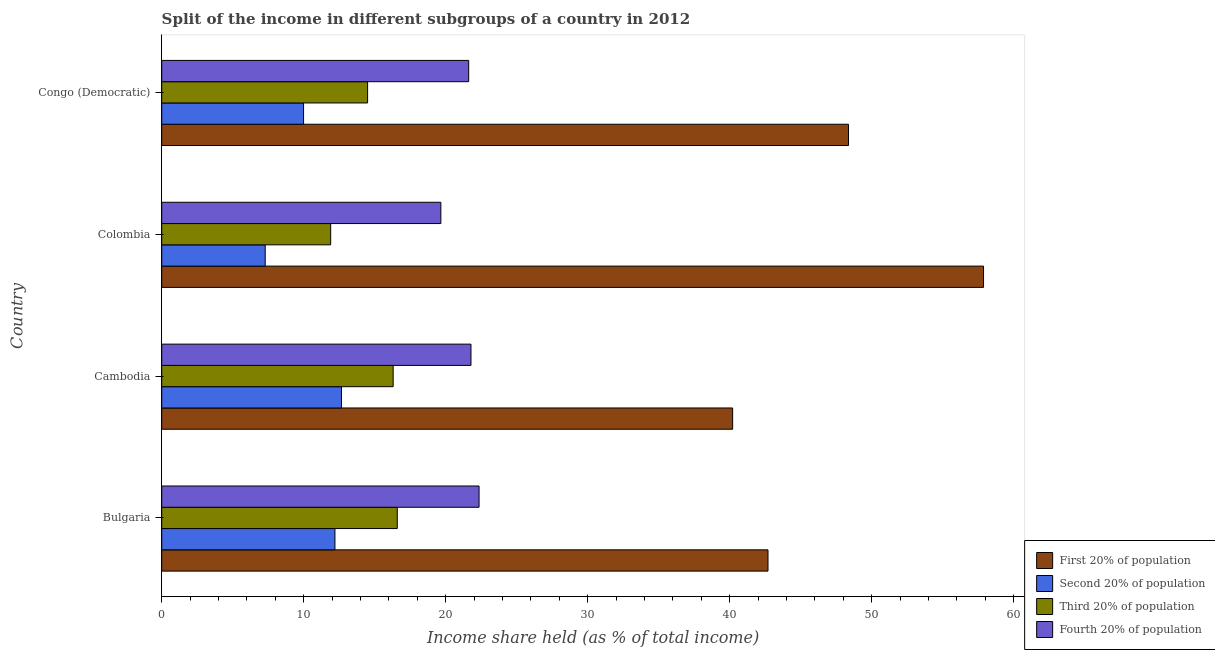How many different coloured bars are there?
Your answer should be very brief. 4. How many groups of bars are there?
Provide a succinct answer. 4. Are the number of bars per tick equal to the number of legend labels?
Give a very brief answer. Yes. How many bars are there on the 1st tick from the top?
Your answer should be very brief. 4. What is the label of the 3rd group of bars from the top?
Offer a very short reply. Cambodia. What is the share of the income held by fourth 20% of the population in Congo (Democratic)?
Offer a very short reply. 21.62. Across all countries, what is the maximum share of the income held by first 20% of the population?
Provide a short and direct response. 57.88. Across all countries, what is the minimum share of the income held by third 20% of the population?
Provide a short and direct response. 11.9. In which country was the share of the income held by second 20% of the population maximum?
Provide a short and direct response. Cambodia. What is the total share of the income held by third 20% of the population in the graph?
Keep it short and to the point. 59.29. What is the difference between the share of the income held by second 20% of the population in Bulgaria and that in Cambodia?
Give a very brief answer. -0.46. What is the difference between the share of the income held by second 20% of the population in Bulgaria and the share of the income held by first 20% of the population in Congo (Democratic)?
Give a very brief answer. -36.17. What is the average share of the income held by first 20% of the population per country?
Offer a terse response. 47.29. What is the difference between the share of the income held by fourth 20% of the population and share of the income held by second 20% of the population in Colombia?
Provide a short and direct response. 12.37. What is the ratio of the share of the income held by second 20% of the population in Colombia to that in Congo (Democratic)?
Offer a very short reply. 0.73. What is the difference between the highest and the second highest share of the income held by second 20% of the population?
Ensure brevity in your answer.  0.46. What is the difference between the highest and the lowest share of the income held by fourth 20% of the population?
Your answer should be very brief. 2.69. What does the 1st bar from the top in Bulgaria represents?
Offer a very short reply. Fourth 20% of population. What does the 4th bar from the bottom in Cambodia represents?
Provide a short and direct response. Fourth 20% of population. How many bars are there?
Give a very brief answer. 16. How many countries are there in the graph?
Ensure brevity in your answer.  4. Are the values on the major ticks of X-axis written in scientific E-notation?
Provide a short and direct response. No. Does the graph contain any zero values?
Provide a short and direct response. No. Does the graph contain grids?
Keep it short and to the point. No. How are the legend labels stacked?
Your response must be concise. Vertical. What is the title of the graph?
Offer a very short reply. Split of the income in different subgroups of a country in 2012. Does "UNDP" appear as one of the legend labels in the graph?
Offer a very short reply. No. What is the label or title of the X-axis?
Offer a very short reply. Income share held (as % of total income). What is the label or title of the Y-axis?
Give a very brief answer. Country. What is the Income share held (as % of total income) in First 20% of population in Bulgaria?
Your response must be concise. 42.7. What is the Income share held (as % of total income) in Second 20% of population in Bulgaria?
Ensure brevity in your answer.  12.2. What is the Income share held (as % of total income) of Third 20% of population in Bulgaria?
Your answer should be very brief. 16.59. What is the Income share held (as % of total income) of Fourth 20% of population in Bulgaria?
Provide a short and direct response. 22.35. What is the Income share held (as % of total income) in First 20% of population in Cambodia?
Your response must be concise. 40.21. What is the Income share held (as % of total income) in Second 20% of population in Cambodia?
Ensure brevity in your answer.  12.66. What is the Income share held (as % of total income) of Fourth 20% of population in Cambodia?
Provide a succinct answer. 21.78. What is the Income share held (as % of total income) of First 20% of population in Colombia?
Keep it short and to the point. 57.88. What is the Income share held (as % of total income) of Second 20% of population in Colombia?
Your response must be concise. 7.29. What is the Income share held (as % of total income) in Fourth 20% of population in Colombia?
Offer a very short reply. 19.66. What is the Income share held (as % of total income) of First 20% of population in Congo (Democratic)?
Your answer should be compact. 48.37. What is the Income share held (as % of total income) of Second 20% of population in Congo (Democratic)?
Provide a short and direct response. 9.99. What is the Income share held (as % of total income) of Third 20% of population in Congo (Democratic)?
Give a very brief answer. 14.5. What is the Income share held (as % of total income) of Fourth 20% of population in Congo (Democratic)?
Provide a short and direct response. 21.62. Across all countries, what is the maximum Income share held (as % of total income) in First 20% of population?
Give a very brief answer. 57.88. Across all countries, what is the maximum Income share held (as % of total income) of Second 20% of population?
Provide a short and direct response. 12.66. Across all countries, what is the maximum Income share held (as % of total income) of Third 20% of population?
Give a very brief answer. 16.59. Across all countries, what is the maximum Income share held (as % of total income) of Fourth 20% of population?
Offer a terse response. 22.35. Across all countries, what is the minimum Income share held (as % of total income) in First 20% of population?
Make the answer very short. 40.21. Across all countries, what is the minimum Income share held (as % of total income) of Second 20% of population?
Provide a short and direct response. 7.29. Across all countries, what is the minimum Income share held (as % of total income) of Third 20% of population?
Your answer should be compact. 11.9. Across all countries, what is the minimum Income share held (as % of total income) in Fourth 20% of population?
Provide a succinct answer. 19.66. What is the total Income share held (as % of total income) of First 20% of population in the graph?
Provide a short and direct response. 189.16. What is the total Income share held (as % of total income) in Second 20% of population in the graph?
Make the answer very short. 42.14. What is the total Income share held (as % of total income) of Third 20% of population in the graph?
Ensure brevity in your answer.  59.29. What is the total Income share held (as % of total income) of Fourth 20% of population in the graph?
Provide a short and direct response. 85.41. What is the difference between the Income share held (as % of total income) of First 20% of population in Bulgaria and that in Cambodia?
Ensure brevity in your answer.  2.49. What is the difference between the Income share held (as % of total income) in Second 20% of population in Bulgaria and that in Cambodia?
Your answer should be very brief. -0.46. What is the difference between the Income share held (as % of total income) in Third 20% of population in Bulgaria and that in Cambodia?
Your answer should be very brief. 0.29. What is the difference between the Income share held (as % of total income) in Fourth 20% of population in Bulgaria and that in Cambodia?
Keep it short and to the point. 0.57. What is the difference between the Income share held (as % of total income) in First 20% of population in Bulgaria and that in Colombia?
Provide a short and direct response. -15.18. What is the difference between the Income share held (as % of total income) in Second 20% of population in Bulgaria and that in Colombia?
Your answer should be compact. 4.91. What is the difference between the Income share held (as % of total income) of Third 20% of population in Bulgaria and that in Colombia?
Provide a succinct answer. 4.69. What is the difference between the Income share held (as % of total income) in Fourth 20% of population in Bulgaria and that in Colombia?
Keep it short and to the point. 2.69. What is the difference between the Income share held (as % of total income) of First 20% of population in Bulgaria and that in Congo (Democratic)?
Provide a succinct answer. -5.67. What is the difference between the Income share held (as % of total income) in Second 20% of population in Bulgaria and that in Congo (Democratic)?
Ensure brevity in your answer.  2.21. What is the difference between the Income share held (as % of total income) in Third 20% of population in Bulgaria and that in Congo (Democratic)?
Your answer should be very brief. 2.09. What is the difference between the Income share held (as % of total income) in Fourth 20% of population in Bulgaria and that in Congo (Democratic)?
Provide a succinct answer. 0.73. What is the difference between the Income share held (as % of total income) in First 20% of population in Cambodia and that in Colombia?
Provide a short and direct response. -17.67. What is the difference between the Income share held (as % of total income) of Second 20% of population in Cambodia and that in Colombia?
Your response must be concise. 5.37. What is the difference between the Income share held (as % of total income) of Third 20% of population in Cambodia and that in Colombia?
Provide a short and direct response. 4.4. What is the difference between the Income share held (as % of total income) of Fourth 20% of population in Cambodia and that in Colombia?
Your answer should be very brief. 2.12. What is the difference between the Income share held (as % of total income) of First 20% of population in Cambodia and that in Congo (Democratic)?
Provide a short and direct response. -8.16. What is the difference between the Income share held (as % of total income) of Second 20% of population in Cambodia and that in Congo (Democratic)?
Make the answer very short. 2.67. What is the difference between the Income share held (as % of total income) in Third 20% of population in Cambodia and that in Congo (Democratic)?
Your answer should be compact. 1.8. What is the difference between the Income share held (as % of total income) in Fourth 20% of population in Cambodia and that in Congo (Democratic)?
Give a very brief answer. 0.16. What is the difference between the Income share held (as % of total income) in First 20% of population in Colombia and that in Congo (Democratic)?
Ensure brevity in your answer.  9.51. What is the difference between the Income share held (as % of total income) of Second 20% of population in Colombia and that in Congo (Democratic)?
Provide a short and direct response. -2.7. What is the difference between the Income share held (as % of total income) in Fourth 20% of population in Colombia and that in Congo (Democratic)?
Provide a succinct answer. -1.96. What is the difference between the Income share held (as % of total income) of First 20% of population in Bulgaria and the Income share held (as % of total income) of Second 20% of population in Cambodia?
Offer a terse response. 30.04. What is the difference between the Income share held (as % of total income) in First 20% of population in Bulgaria and the Income share held (as % of total income) in Third 20% of population in Cambodia?
Your answer should be compact. 26.4. What is the difference between the Income share held (as % of total income) in First 20% of population in Bulgaria and the Income share held (as % of total income) in Fourth 20% of population in Cambodia?
Offer a terse response. 20.92. What is the difference between the Income share held (as % of total income) in Second 20% of population in Bulgaria and the Income share held (as % of total income) in Third 20% of population in Cambodia?
Provide a short and direct response. -4.1. What is the difference between the Income share held (as % of total income) in Second 20% of population in Bulgaria and the Income share held (as % of total income) in Fourth 20% of population in Cambodia?
Make the answer very short. -9.58. What is the difference between the Income share held (as % of total income) in Third 20% of population in Bulgaria and the Income share held (as % of total income) in Fourth 20% of population in Cambodia?
Keep it short and to the point. -5.19. What is the difference between the Income share held (as % of total income) in First 20% of population in Bulgaria and the Income share held (as % of total income) in Second 20% of population in Colombia?
Your answer should be compact. 35.41. What is the difference between the Income share held (as % of total income) in First 20% of population in Bulgaria and the Income share held (as % of total income) in Third 20% of population in Colombia?
Your answer should be compact. 30.8. What is the difference between the Income share held (as % of total income) of First 20% of population in Bulgaria and the Income share held (as % of total income) of Fourth 20% of population in Colombia?
Ensure brevity in your answer.  23.04. What is the difference between the Income share held (as % of total income) in Second 20% of population in Bulgaria and the Income share held (as % of total income) in Third 20% of population in Colombia?
Your answer should be compact. 0.3. What is the difference between the Income share held (as % of total income) in Second 20% of population in Bulgaria and the Income share held (as % of total income) in Fourth 20% of population in Colombia?
Ensure brevity in your answer.  -7.46. What is the difference between the Income share held (as % of total income) in Third 20% of population in Bulgaria and the Income share held (as % of total income) in Fourth 20% of population in Colombia?
Your answer should be very brief. -3.07. What is the difference between the Income share held (as % of total income) of First 20% of population in Bulgaria and the Income share held (as % of total income) of Second 20% of population in Congo (Democratic)?
Provide a succinct answer. 32.71. What is the difference between the Income share held (as % of total income) in First 20% of population in Bulgaria and the Income share held (as % of total income) in Third 20% of population in Congo (Democratic)?
Make the answer very short. 28.2. What is the difference between the Income share held (as % of total income) in First 20% of population in Bulgaria and the Income share held (as % of total income) in Fourth 20% of population in Congo (Democratic)?
Provide a short and direct response. 21.08. What is the difference between the Income share held (as % of total income) in Second 20% of population in Bulgaria and the Income share held (as % of total income) in Third 20% of population in Congo (Democratic)?
Your answer should be very brief. -2.3. What is the difference between the Income share held (as % of total income) of Second 20% of population in Bulgaria and the Income share held (as % of total income) of Fourth 20% of population in Congo (Democratic)?
Keep it short and to the point. -9.42. What is the difference between the Income share held (as % of total income) in Third 20% of population in Bulgaria and the Income share held (as % of total income) in Fourth 20% of population in Congo (Democratic)?
Offer a terse response. -5.03. What is the difference between the Income share held (as % of total income) of First 20% of population in Cambodia and the Income share held (as % of total income) of Second 20% of population in Colombia?
Provide a short and direct response. 32.92. What is the difference between the Income share held (as % of total income) in First 20% of population in Cambodia and the Income share held (as % of total income) in Third 20% of population in Colombia?
Provide a short and direct response. 28.31. What is the difference between the Income share held (as % of total income) in First 20% of population in Cambodia and the Income share held (as % of total income) in Fourth 20% of population in Colombia?
Your answer should be compact. 20.55. What is the difference between the Income share held (as % of total income) of Second 20% of population in Cambodia and the Income share held (as % of total income) of Third 20% of population in Colombia?
Your answer should be compact. 0.76. What is the difference between the Income share held (as % of total income) in Second 20% of population in Cambodia and the Income share held (as % of total income) in Fourth 20% of population in Colombia?
Offer a very short reply. -7. What is the difference between the Income share held (as % of total income) of Third 20% of population in Cambodia and the Income share held (as % of total income) of Fourth 20% of population in Colombia?
Make the answer very short. -3.36. What is the difference between the Income share held (as % of total income) of First 20% of population in Cambodia and the Income share held (as % of total income) of Second 20% of population in Congo (Democratic)?
Give a very brief answer. 30.22. What is the difference between the Income share held (as % of total income) in First 20% of population in Cambodia and the Income share held (as % of total income) in Third 20% of population in Congo (Democratic)?
Your answer should be very brief. 25.71. What is the difference between the Income share held (as % of total income) in First 20% of population in Cambodia and the Income share held (as % of total income) in Fourth 20% of population in Congo (Democratic)?
Your response must be concise. 18.59. What is the difference between the Income share held (as % of total income) of Second 20% of population in Cambodia and the Income share held (as % of total income) of Third 20% of population in Congo (Democratic)?
Give a very brief answer. -1.84. What is the difference between the Income share held (as % of total income) of Second 20% of population in Cambodia and the Income share held (as % of total income) of Fourth 20% of population in Congo (Democratic)?
Provide a short and direct response. -8.96. What is the difference between the Income share held (as % of total income) in Third 20% of population in Cambodia and the Income share held (as % of total income) in Fourth 20% of population in Congo (Democratic)?
Offer a terse response. -5.32. What is the difference between the Income share held (as % of total income) in First 20% of population in Colombia and the Income share held (as % of total income) in Second 20% of population in Congo (Democratic)?
Keep it short and to the point. 47.89. What is the difference between the Income share held (as % of total income) in First 20% of population in Colombia and the Income share held (as % of total income) in Third 20% of population in Congo (Democratic)?
Provide a succinct answer. 43.38. What is the difference between the Income share held (as % of total income) in First 20% of population in Colombia and the Income share held (as % of total income) in Fourth 20% of population in Congo (Democratic)?
Give a very brief answer. 36.26. What is the difference between the Income share held (as % of total income) of Second 20% of population in Colombia and the Income share held (as % of total income) of Third 20% of population in Congo (Democratic)?
Your answer should be compact. -7.21. What is the difference between the Income share held (as % of total income) of Second 20% of population in Colombia and the Income share held (as % of total income) of Fourth 20% of population in Congo (Democratic)?
Your answer should be compact. -14.33. What is the difference between the Income share held (as % of total income) of Third 20% of population in Colombia and the Income share held (as % of total income) of Fourth 20% of population in Congo (Democratic)?
Keep it short and to the point. -9.72. What is the average Income share held (as % of total income) of First 20% of population per country?
Provide a short and direct response. 47.29. What is the average Income share held (as % of total income) of Second 20% of population per country?
Offer a very short reply. 10.54. What is the average Income share held (as % of total income) in Third 20% of population per country?
Your answer should be compact. 14.82. What is the average Income share held (as % of total income) of Fourth 20% of population per country?
Offer a very short reply. 21.35. What is the difference between the Income share held (as % of total income) in First 20% of population and Income share held (as % of total income) in Second 20% of population in Bulgaria?
Provide a succinct answer. 30.5. What is the difference between the Income share held (as % of total income) in First 20% of population and Income share held (as % of total income) in Third 20% of population in Bulgaria?
Offer a very short reply. 26.11. What is the difference between the Income share held (as % of total income) of First 20% of population and Income share held (as % of total income) of Fourth 20% of population in Bulgaria?
Your response must be concise. 20.35. What is the difference between the Income share held (as % of total income) of Second 20% of population and Income share held (as % of total income) of Third 20% of population in Bulgaria?
Provide a succinct answer. -4.39. What is the difference between the Income share held (as % of total income) of Second 20% of population and Income share held (as % of total income) of Fourth 20% of population in Bulgaria?
Give a very brief answer. -10.15. What is the difference between the Income share held (as % of total income) of Third 20% of population and Income share held (as % of total income) of Fourth 20% of population in Bulgaria?
Provide a succinct answer. -5.76. What is the difference between the Income share held (as % of total income) in First 20% of population and Income share held (as % of total income) in Second 20% of population in Cambodia?
Provide a short and direct response. 27.55. What is the difference between the Income share held (as % of total income) in First 20% of population and Income share held (as % of total income) in Third 20% of population in Cambodia?
Offer a terse response. 23.91. What is the difference between the Income share held (as % of total income) of First 20% of population and Income share held (as % of total income) of Fourth 20% of population in Cambodia?
Provide a short and direct response. 18.43. What is the difference between the Income share held (as % of total income) in Second 20% of population and Income share held (as % of total income) in Third 20% of population in Cambodia?
Provide a short and direct response. -3.64. What is the difference between the Income share held (as % of total income) of Second 20% of population and Income share held (as % of total income) of Fourth 20% of population in Cambodia?
Offer a very short reply. -9.12. What is the difference between the Income share held (as % of total income) in Third 20% of population and Income share held (as % of total income) in Fourth 20% of population in Cambodia?
Give a very brief answer. -5.48. What is the difference between the Income share held (as % of total income) of First 20% of population and Income share held (as % of total income) of Second 20% of population in Colombia?
Make the answer very short. 50.59. What is the difference between the Income share held (as % of total income) of First 20% of population and Income share held (as % of total income) of Third 20% of population in Colombia?
Give a very brief answer. 45.98. What is the difference between the Income share held (as % of total income) in First 20% of population and Income share held (as % of total income) in Fourth 20% of population in Colombia?
Ensure brevity in your answer.  38.22. What is the difference between the Income share held (as % of total income) of Second 20% of population and Income share held (as % of total income) of Third 20% of population in Colombia?
Make the answer very short. -4.61. What is the difference between the Income share held (as % of total income) of Second 20% of population and Income share held (as % of total income) of Fourth 20% of population in Colombia?
Your answer should be compact. -12.37. What is the difference between the Income share held (as % of total income) in Third 20% of population and Income share held (as % of total income) in Fourth 20% of population in Colombia?
Ensure brevity in your answer.  -7.76. What is the difference between the Income share held (as % of total income) in First 20% of population and Income share held (as % of total income) in Second 20% of population in Congo (Democratic)?
Offer a terse response. 38.38. What is the difference between the Income share held (as % of total income) of First 20% of population and Income share held (as % of total income) of Third 20% of population in Congo (Democratic)?
Provide a succinct answer. 33.87. What is the difference between the Income share held (as % of total income) in First 20% of population and Income share held (as % of total income) in Fourth 20% of population in Congo (Democratic)?
Your answer should be compact. 26.75. What is the difference between the Income share held (as % of total income) in Second 20% of population and Income share held (as % of total income) in Third 20% of population in Congo (Democratic)?
Ensure brevity in your answer.  -4.51. What is the difference between the Income share held (as % of total income) in Second 20% of population and Income share held (as % of total income) in Fourth 20% of population in Congo (Democratic)?
Give a very brief answer. -11.63. What is the difference between the Income share held (as % of total income) of Third 20% of population and Income share held (as % of total income) of Fourth 20% of population in Congo (Democratic)?
Your answer should be very brief. -7.12. What is the ratio of the Income share held (as % of total income) in First 20% of population in Bulgaria to that in Cambodia?
Offer a very short reply. 1.06. What is the ratio of the Income share held (as % of total income) of Second 20% of population in Bulgaria to that in Cambodia?
Ensure brevity in your answer.  0.96. What is the ratio of the Income share held (as % of total income) of Third 20% of population in Bulgaria to that in Cambodia?
Offer a terse response. 1.02. What is the ratio of the Income share held (as % of total income) of Fourth 20% of population in Bulgaria to that in Cambodia?
Your answer should be very brief. 1.03. What is the ratio of the Income share held (as % of total income) of First 20% of population in Bulgaria to that in Colombia?
Provide a short and direct response. 0.74. What is the ratio of the Income share held (as % of total income) of Second 20% of population in Bulgaria to that in Colombia?
Ensure brevity in your answer.  1.67. What is the ratio of the Income share held (as % of total income) in Third 20% of population in Bulgaria to that in Colombia?
Your answer should be very brief. 1.39. What is the ratio of the Income share held (as % of total income) of Fourth 20% of population in Bulgaria to that in Colombia?
Provide a short and direct response. 1.14. What is the ratio of the Income share held (as % of total income) in First 20% of population in Bulgaria to that in Congo (Democratic)?
Your response must be concise. 0.88. What is the ratio of the Income share held (as % of total income) in Second 20% of population in Bulgaria to that in Congo (Democratic)?
Provide a succinct answer. 1.22. What is the ratio of the Income share held (as % of total income) in Third 20% of population in Bulgaria to that in Congo (Democratic)?
Offer a very short reply. 1.14. What is the ratio of the Income share held (as % of total income) of Fourth 20% of population in Bulgaria to that in Congo (Democratic)?
Offer a terse response. 1.03. What is the ratio of the Income share held (as % of total income) of First 20% of population in Cambodia to that in Colombia?
Your answer should be very brief. 0.69. What is the ratio of the Income share held (as % of total income) in Second 20% of population in Cambodia to that in Colombia?
Ensure brevity in your answer.  1.74. What is the ratio of the Income share held (as % of total income) of Third 20% of population in Cambodia to that in Colombia?
Make the answer very short. 1.37. What is the ratio of the Income share held (as % of total income) of Fourth 20% of population in Cambodia to that in Colombia?
Offer a very short reply. 1.11. What is the ratio of the Income share held (as % of total income) of First 20% of population in Cambodia to that in Congo (Democratic)?
Your response must be concise. 0.83. What is the ratio of the Income share held (as % of total income) of Second 20% of population in Cambodia to that in Congo (Democratic)?
Your answer should be compact. 1.27. What is the ratio of the Income share held (as % of total income) in Third 20% of population in Cambodia to that in Congo (Democratic)?
Ensure brevity in your answer.  1.12. What is the ratio of the Income share held (as % of total income) of Fourth 20% of population in Cambodia to that in Congo (Democratic)?
Provide a short and direct response. 1.01. What is the ratio of the Income share held (as % of total income) in First 20% of population in Colombia to that in Congo (Democratic)?
Your answer should be very brief. 1.2. What is the ratio of the Income share held (as % of total income) of Second 20% of population in Colombia to that in Congo (Democratic)?
Your answer should be compact. 0.73. What is the ratio of the Income share held (as % of total income) in Third 20% of population in Colombia to that in Congo (Democratic)?
Offer a terse response. 0.82. What is the ratio of the Income share held (as % of total income) in Fourth 20% of population in Colombia to that in Congo (Democratic)?
Provide a short and direct response. 0.91. What is the difference between the highest and the second highest Income share held (as % of total income) in First 20% of population?
Give a very brief answer. 9.51. What is the difference between the highest and the second highest Income share held (as % of total income) of Second 20% of population?
Provide a succinct answer. 0.46. What is the difference between the highest and the second highest Income share held (as % of total income) in Third 20% of population?
Your answer should be compact. 0.29. What is the difference between the highest and the second highest Income share held (as % of total income) of Fourth 20% of population?
Your answer should be compact. 0.57. What is the difference between the highest and the lowest Income share held (as % of total income) in First 20% of population?
Your response must be concise. 17.67. What is the difference between the highest and the lowest Income share held (as % of total income) in Second 20% of population?
Offer a very short reply. 5.37. What is the difference between the highest and the lowest Income share held (as % of total income) of Third 20% of population?
Provide a succinct answer. 4.69. What is the difference between the highest and the lowest Income share held (as % of total income) in Fourth 20% of population?
Your response must be concise. 2.69. 